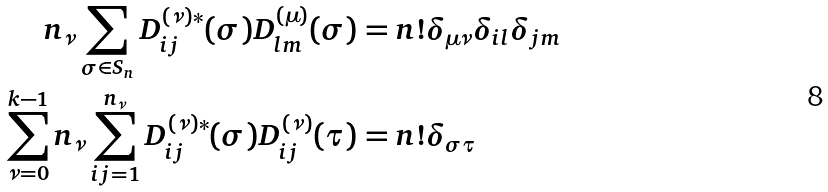Convert formula to latex. <formula><loc_0><loc_0><loc_500><loc_500>n _ { \nu } \sum _ { \sigma \in S _ { n } } D ^ { ( \nu ) \ast } _ { i j } ( \sigma ) D ^ { ( \mu ) } _ { l m } ( \sigma ) & = n ! \delta _ { \mu \nu } \delta _ { i l } \delta _ { j m } \\ \sum _ { \nu = 0 } ^ { k - 1 } n _ { \nu } \sum _ { i j = 1 } ^ { n _ { \nu } } D ^ { ( \nu ) \ast } _ { i j } ( \sigma ) D ^ { ( \nu ) } _ { i j } ( \tau ) & = n ! \delta _ { \sigma \tau }</formula> 